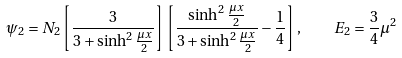<formula> <loc_0><loc_0><loc_500><loc_500>\psi _ { 2 } = N _ { 2 } \left [ \frac { 3 } { 3 + \sinh ^ { 2 } \frac { \mu x } { 2 } } \right ] \left [ \frac { \sinh ^ { 2 } \frac { \mu x } { 2 } } { 3 + \sinh ^ { 2 } \frac { \mu x } { 2 } } - \frac { 1 } { 4 } \right ] , \quad E _ { 2 } = \frac { 3 } { 4 } \mu ^ { 2 }</formula> 